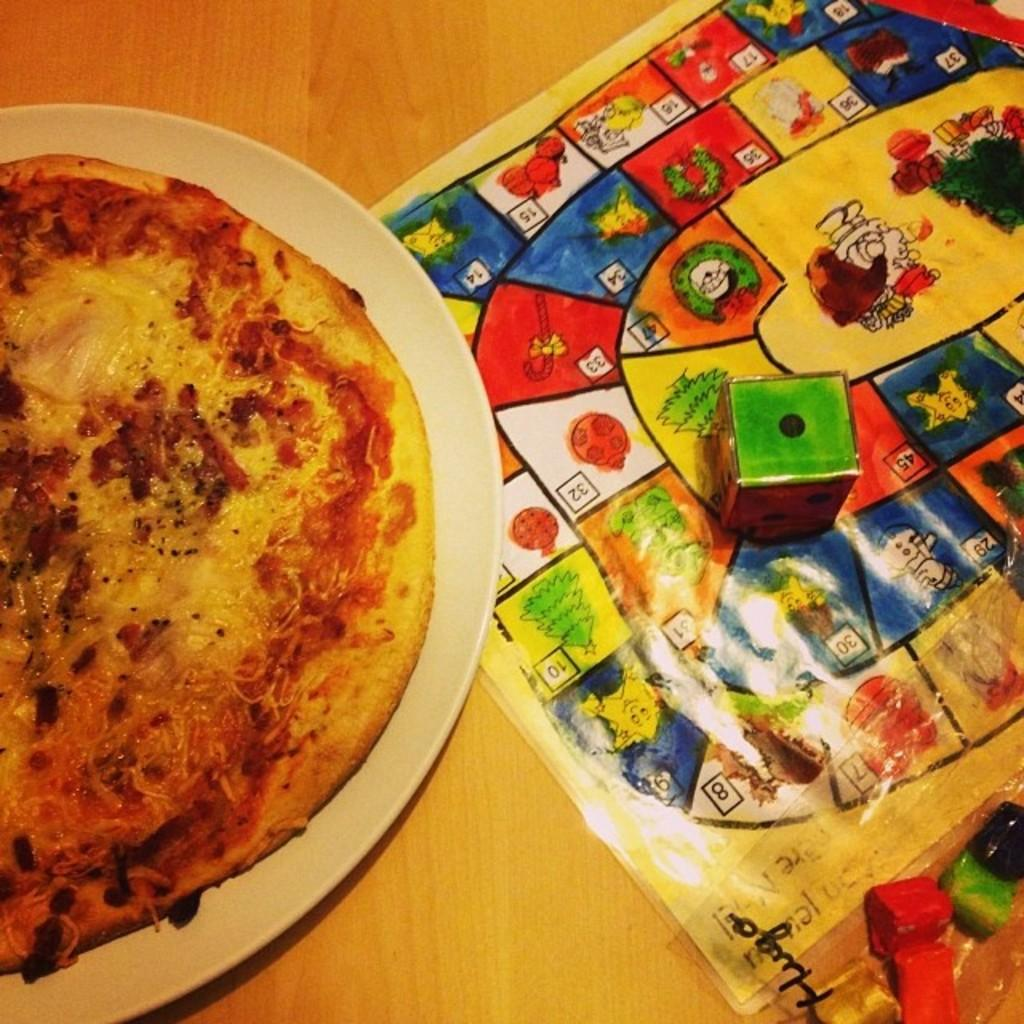What type of surface is visible in the image? There is a wooden surface in the image. What is placed on the wooden surface? There is a white plate on the wooden surface. What is on the plate? There is a food item on the plate. What other objects can be seen in the image? There is a dice and a game sheet in the image. How much sugar is present in the food item on the plate? There is no information about the sugar content of the food item on the plate, as it is not mentioned in the facts. --- Facts: 1. There is a person sitting on a chair in the image. 2. The person is holding a book. 3. The book has a blue cover. 4. There is a table next to the chair. 5. There is a lamp on the table. Absurd Topics: ocean, dance, parrot Conversation: What is the person in the image doing? The person is sitting on a chair in the image. What is the person holding? The person is holding a book. What color is the book's cover? The book has a blue cover. What is located next to the chair? There is a table next to the chair. What object is on the table? There is a lamp on the table. Reasoning: Let's think step by step in order to produce the conversation. We start by identifying the main subject in the image, which is the person sitting on a chair. Then, we describe the object the person is holding, which is a book with a blue cover. Next, we mention the other objects present in the image, which are the table and the lamp. Each question is designed to elicit a specific detail about the image that is known from the provided facts. Absurd Question/Answer: Can you see any parrots flying over the ocean in the image? There is no mention of an ocean or parrots in the image, so we cannot see any parrots flying over the ocean. 